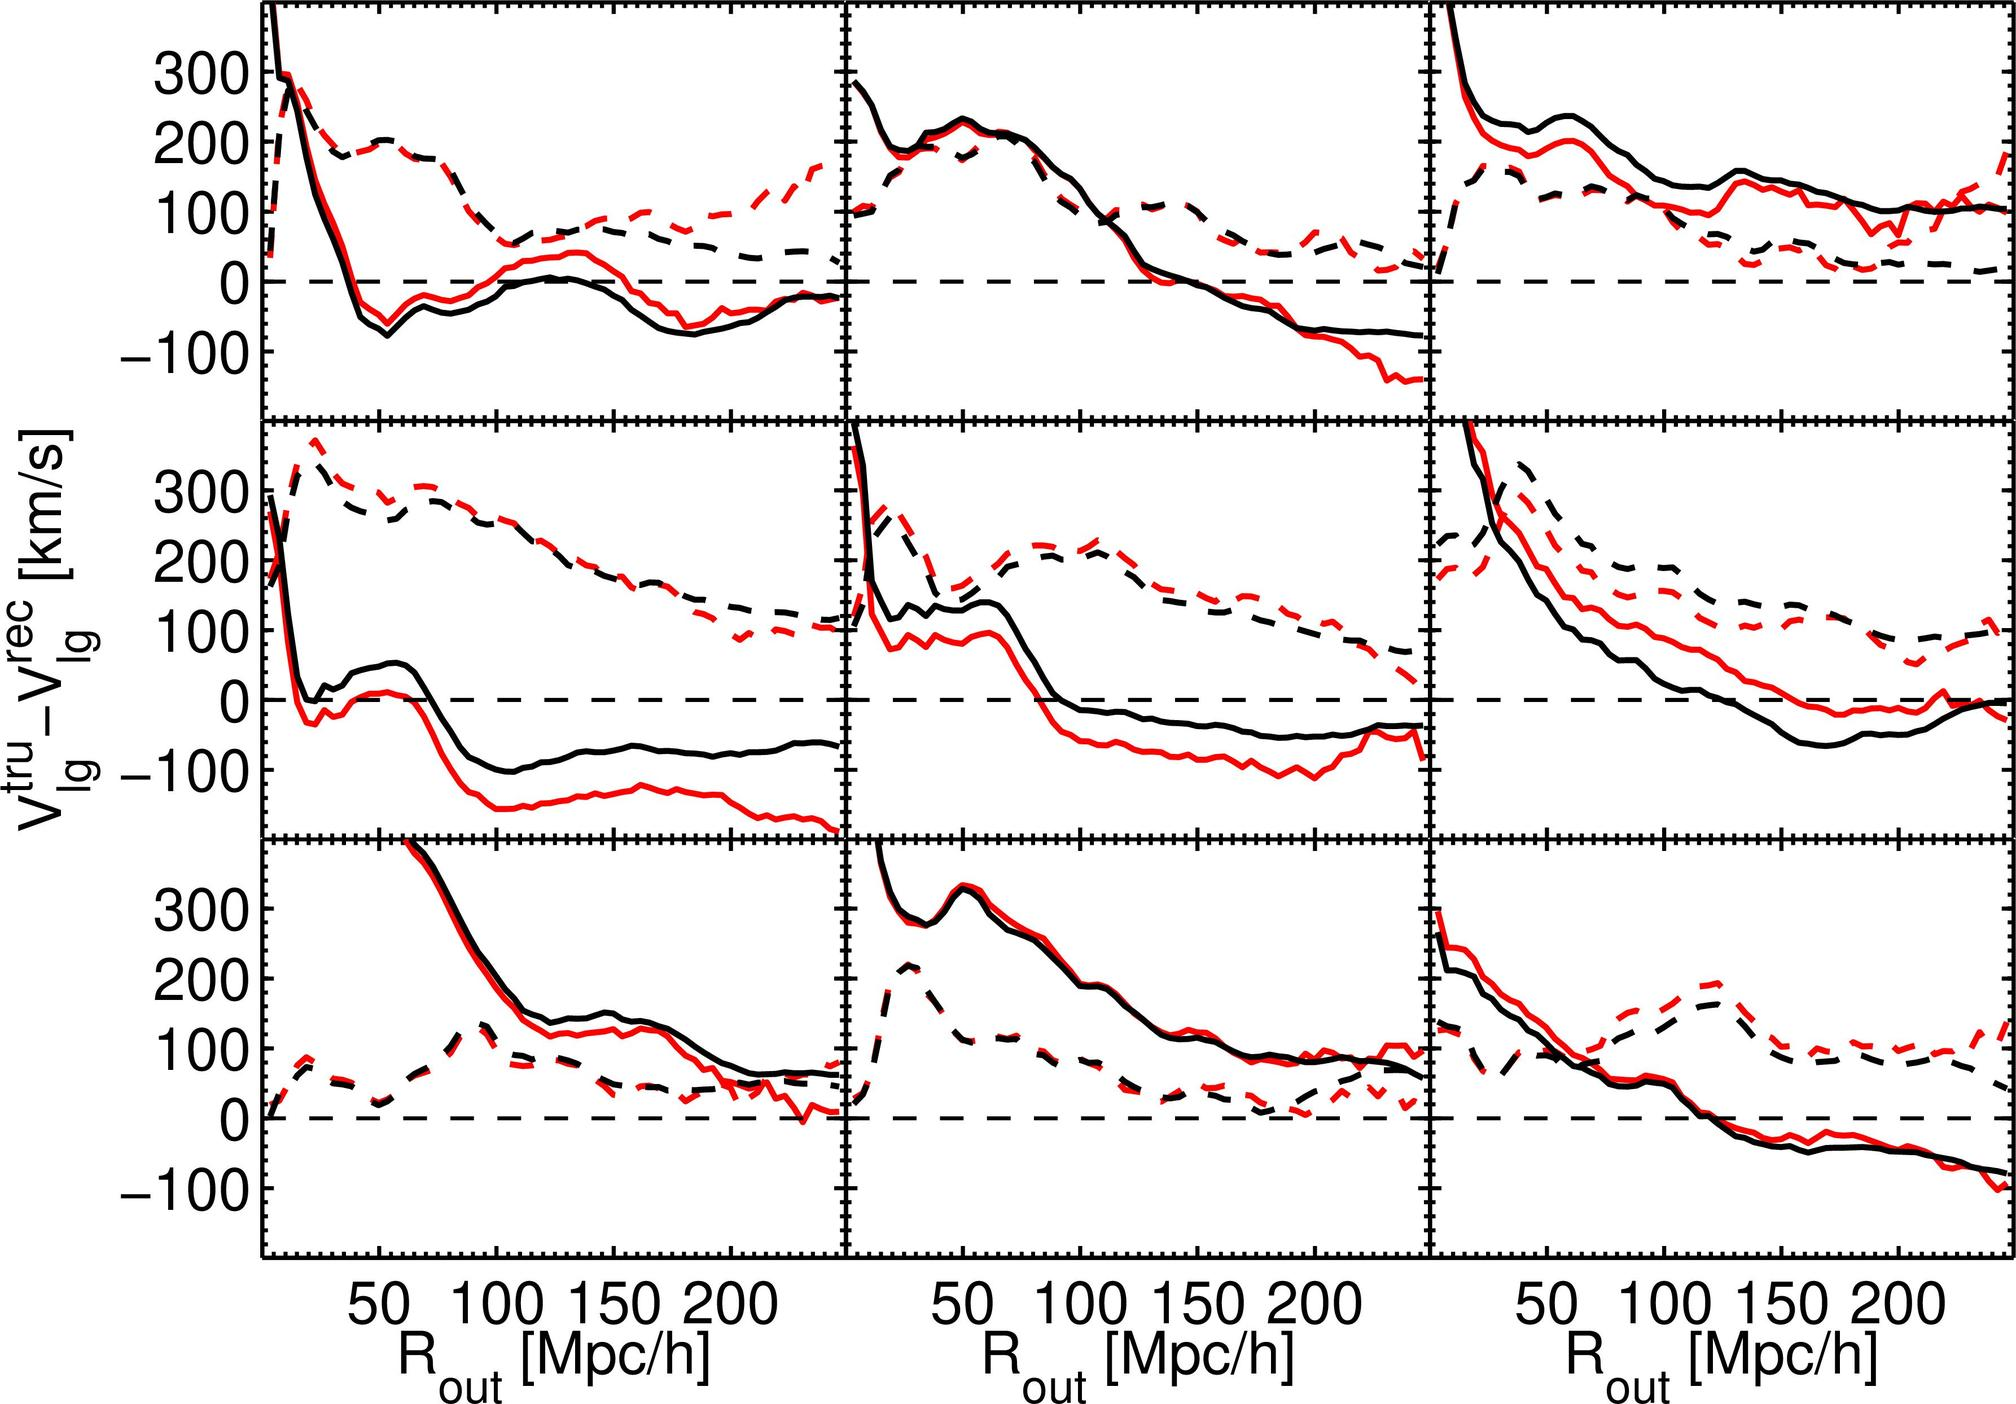What does the dashed line represent in these plots? The average velocity of local galaxies. The error range for the velocity measurements. The theoretical prediction for the velocity of local galaxies. The observational data points for galaxy velocities. - The dashed lines in scientific plots often represent a model or theoretical prediction that the experimental data (solid lines) is being compared to. Since these plots show velocity measurements, the dashed lines likely represent a theoretical prediction for the velocity of local galaxies. Therefore, the correct answer is C. 